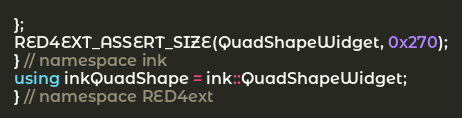Convert code to text. <code><loc_0><loc_0><loc_500><loc_500><_C++_>};
RED4EXT_ASSERT_SIZE(QuadShapeWidget, 0x270);
} // namespace ink
using inkQuadShape = ink::QuadShapeWidget;
} // namespace RED4ext
</code> 